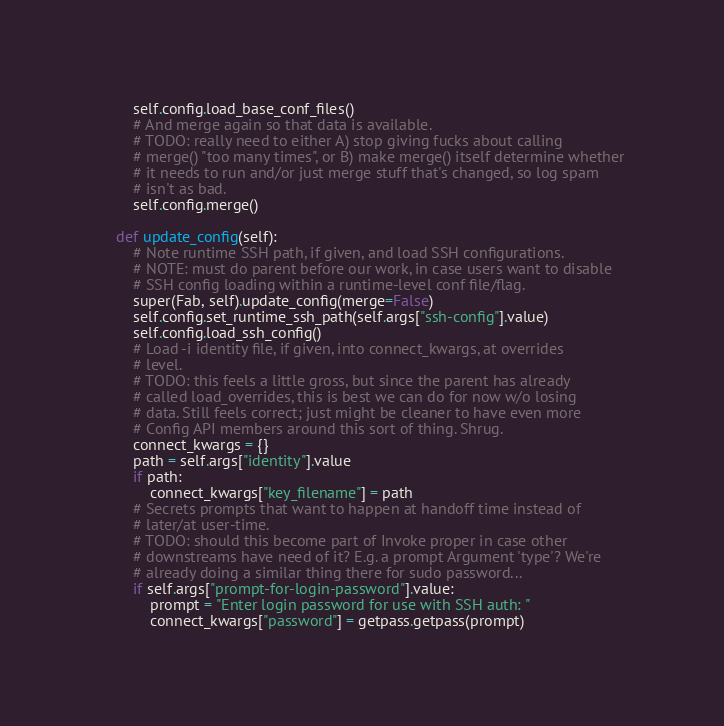<code> <loc_0><loc_0><loc_500><loc_500><_Python_>        self.config.load_base_conf_files()
        # And merge again so that data is available.
        # TODO: really need to either A) stop giving fucks about calling
        # merge() "too many times", or B) make merge() itself determine whether
        # it needs to run and/or just merge stuff that's changed, so log spam
        # isn't as bad.
        self.config.merge()

    def update_config(self):
        # Note runtime SSH path, if given, and load SSH configurations.
        # NOTE: must do parent before our work, in case users want to disable
        # SSH config loading within a runtime-level conf file/flag.
        super(Fab, self).update_config(merge=False)
        self.config.set_runtime_ssh_path(self.args["ssh-config"].value)
        self.config.load_ssh_config()
        # Load -i identity file, if given, into connect_kwargs, at overrides
        # level.
        # TODO: this feels a little gross, but since the parent has already
        # called load_overrides, this is best we can do for now w/o losing
        # data. Still feels correct; just might be cleaner to have even more
        # Config API members around this sort of thing. Shrug.
        connect_kwargs = {}
        path = self.args["identity"].value
        if path:
            connect_kwargs["key_filename"] = path
        # Secrets prompts that want to happen at handoff time instead of
        # later/at user-time.
        # TODO: should this become part of Invoke proper in case other
        # downstreams have need of it? E.g. a prompt Argument 'type'? We're
        # already doing a similar thing there for sudo password...
        if self.args["prompt-for-login-password"].value:
            prompt = "Enter login password for use with SSH auth: "
            connect_kwargs["password"] = getpass.getpass(prompt)</code> 